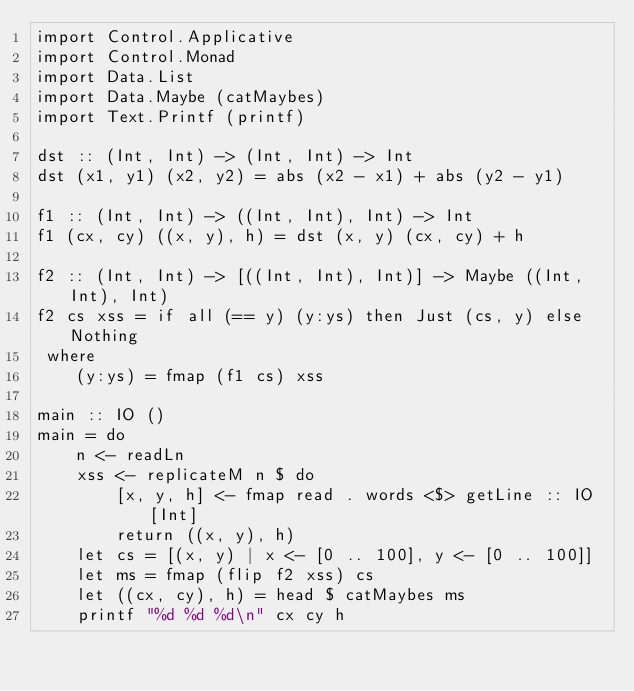<code> <loc_0><loc_0><loc_500><loc_500><_Haskell_>import Control.Applicative
import Control.Monad
import Data.List
import Data.Maybe (catMaybes)
import Text.Printf (printf)

dst :: (Int, Int) -> (Int, Int) -> Int
dst (x1, y1) (x2, y2) = abs (x2 - x1) + abs (y2 - y1)

f1 :: (Int, Int) -> ((Int, Int), Int) -> Int
f1 (cx, cy) ((x, y), h) = dst (x, y) (cx, cy) + h

f2 :: (Int, Int) -> [((Int, Int), Int)] -> Maybe ((Int, Int), Int)
f2 cs xss = if all (== y) (y:ys) then Just (cs, y) else Nothing
 where
    (y:ys) = fmap (f1 cs) xss

main :: IO ()
main = do
    n <- readLn
    xss <- replicateM n $ do
        [x, y, h] <- fmap read . words <$> getLine :: IO [Int]
        return ((x, y), h)
    let cs = [(x, y) | x <- [0 .. 100], y <- [0 .. 100]]
    let ms = fmap (flip f2 xss) cs
    let ((cx, cy), h) = head $ catMaybes ms
    printf "%d %d %d\n" cx cy h</code> 